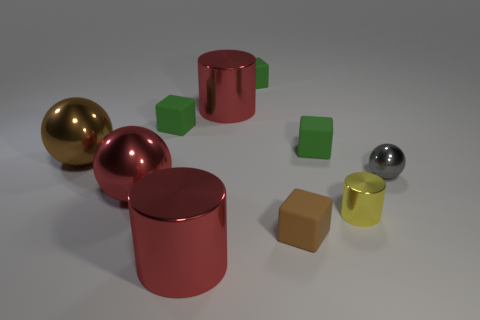The big object that is to the right of the large brown thing and behind the tiny ball is made of what material?
Keep it short and to the point. Metal. There is a tiny object that is the same shape as the big brown thing; what color is it?
Your response must be concise. Gray. There is a red cylinder that is in front of the small ball; are there any small gray metallic things on the left side of it?
Your response must be concise. No. The gray shiny thing has what size?
Make the answer very short. Small. What shape is the small object that is both on the right side of the brown rubber cube and behind the tiny sphere?
Provide a short and direct response. Cube. What number of gray things are either metal objects or metal balls?
Your response must be concise. 1. Is the size of the ball on the right side of the red metal ball the same as the rubber object in front of the small shiny cylinder?
Offer a very short reply. Yes. What number of objects are large cyan rubber balls or metal cylinders?
Provide a short and direct response. 3. Is there a big metallic thing of the same shape as the tiny yellow metal object?
Provide a short and direct response. Yes. Is the number of large metallic objects less than the number of metal objects?
Offer a terse response. Yes. 